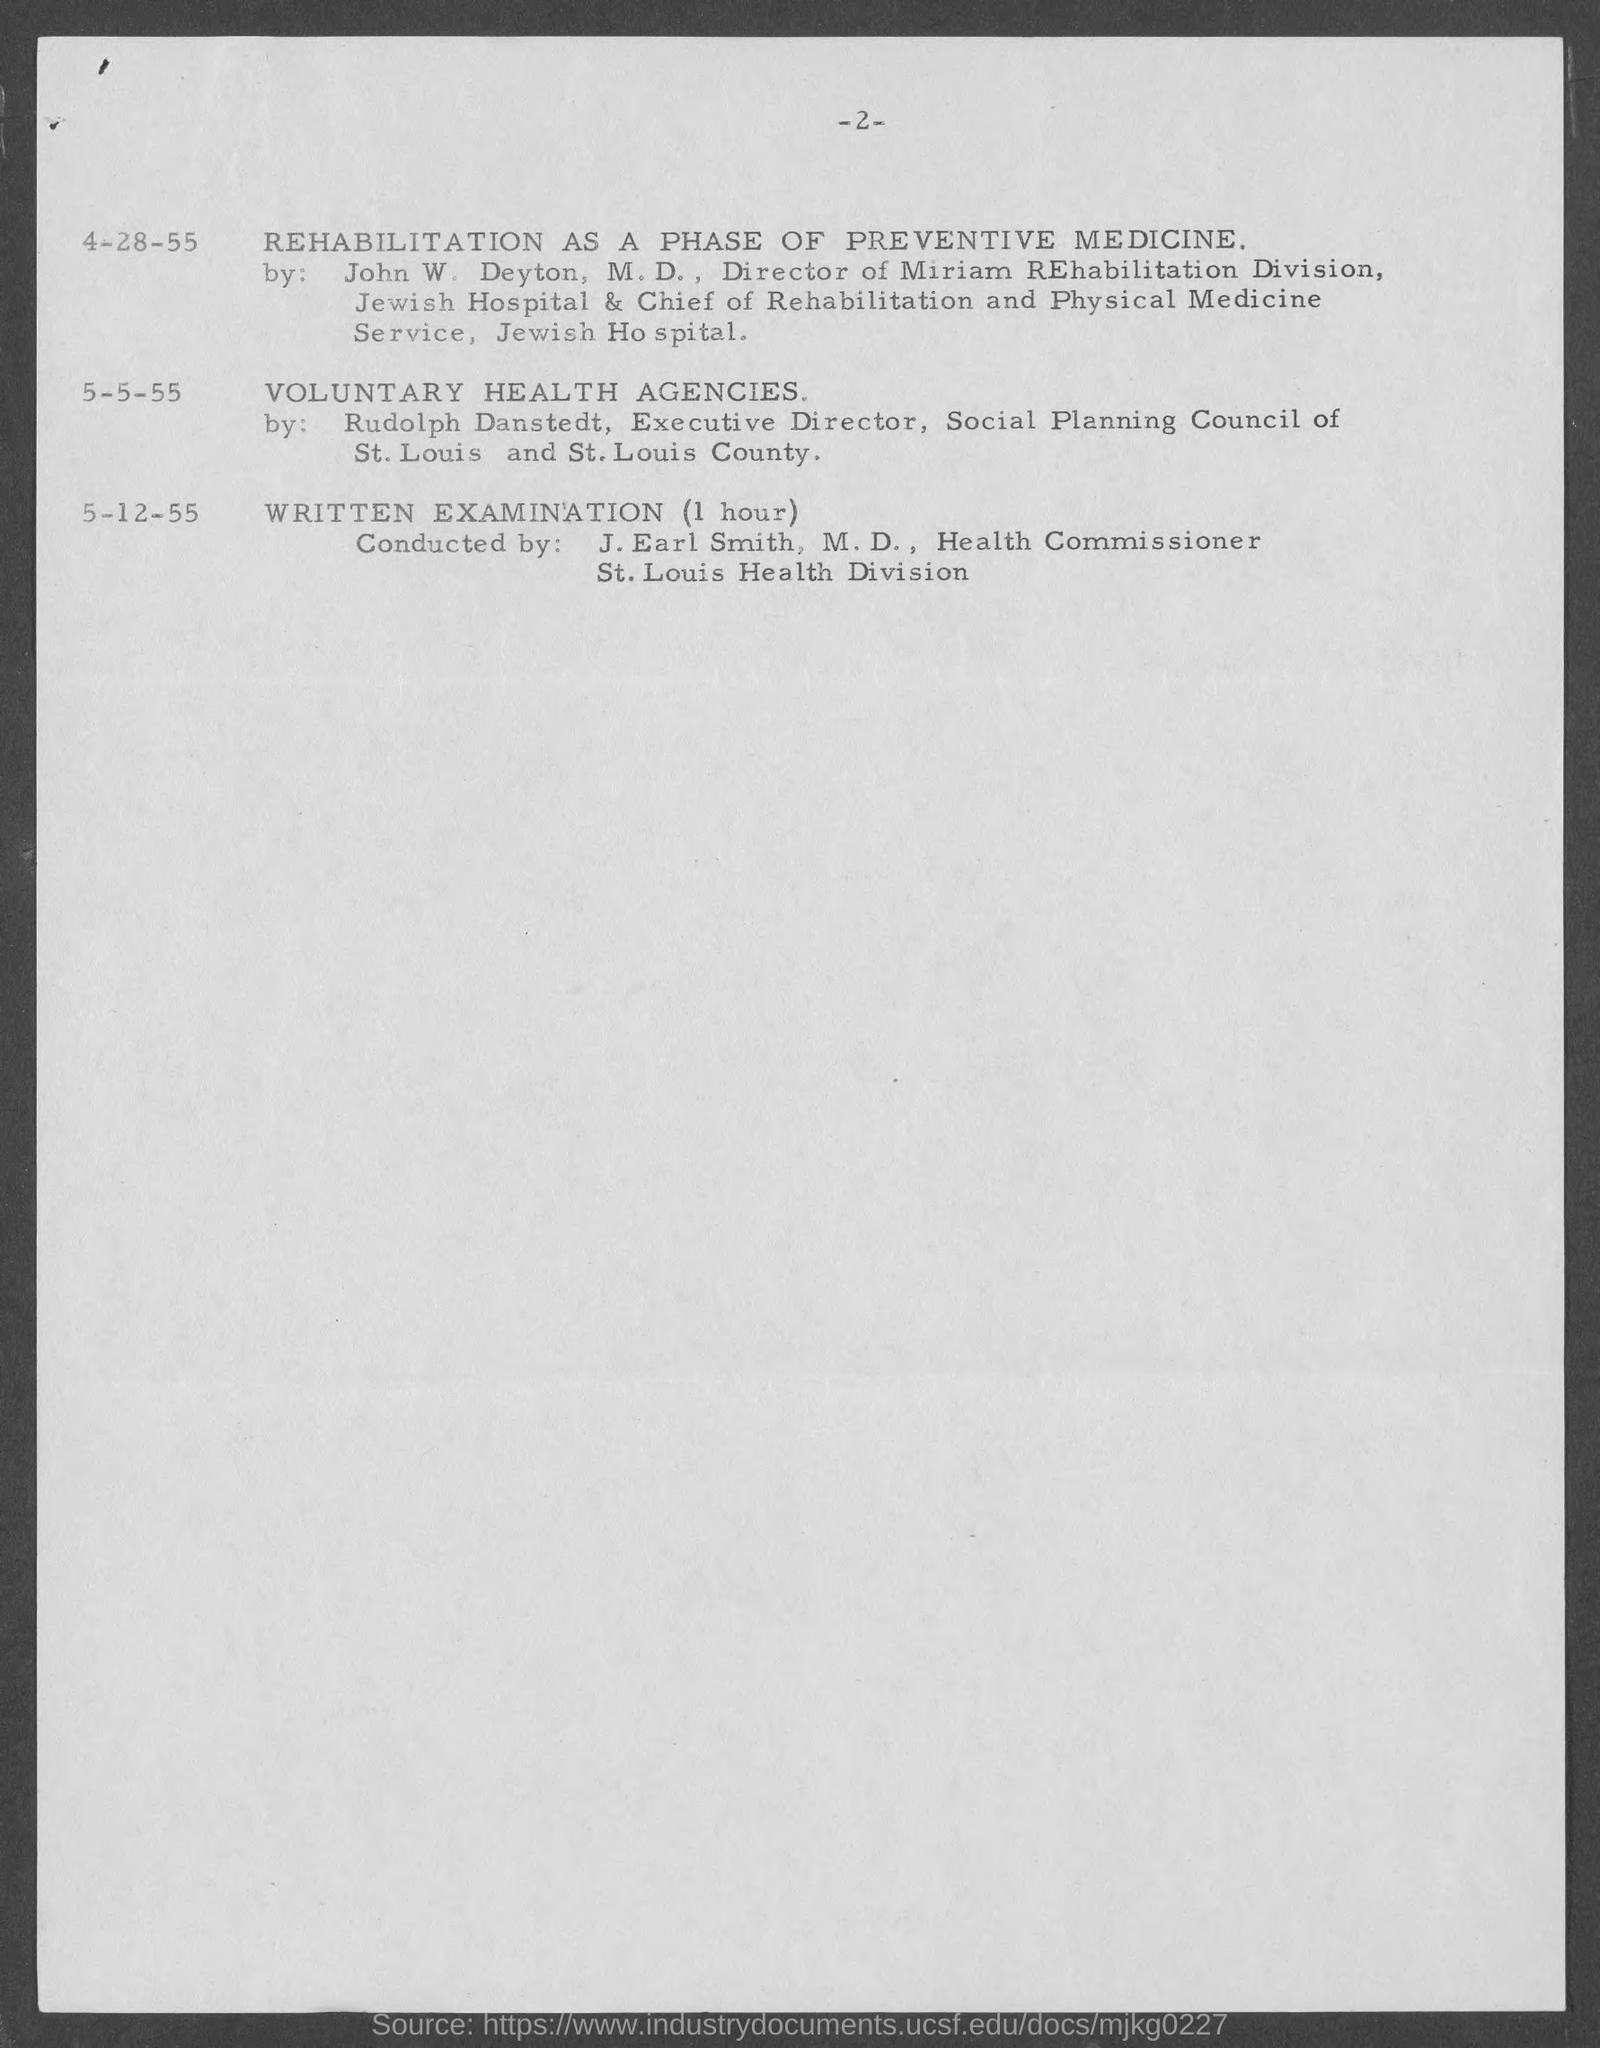Give some essential details in this illustration. J. Earl Smith is the health commissioner. The topic for 4-28-55 was rehabilitation as a phase of preventive medicine. The duration for the written examination is one hour. The written examination is scheduled for December 5th, 1955. 